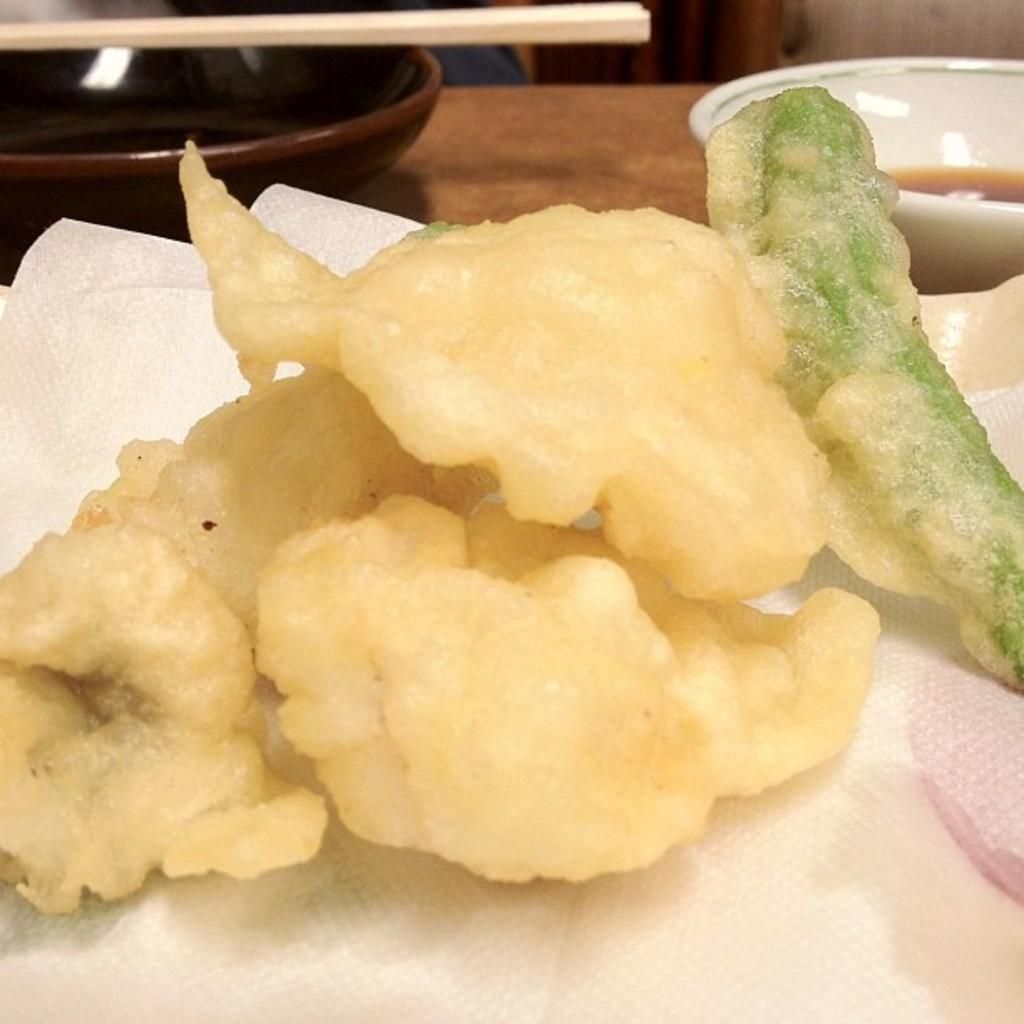What is on the serving plate in the image? The serving plate contains fritters. Are there any utensils on the serving plate? Yes, chopsticks are present on the serving plate. What else can be seen in the image besides the serving plate? There is a sauce bowl in the image. Is there a crown on the fritters in the image? No, there is no crown on the fritters in the image. What type of potato is used to make the fritters in the image? The image does not specify the type of potato used to make the fritters, nor does it show any potatoes. 